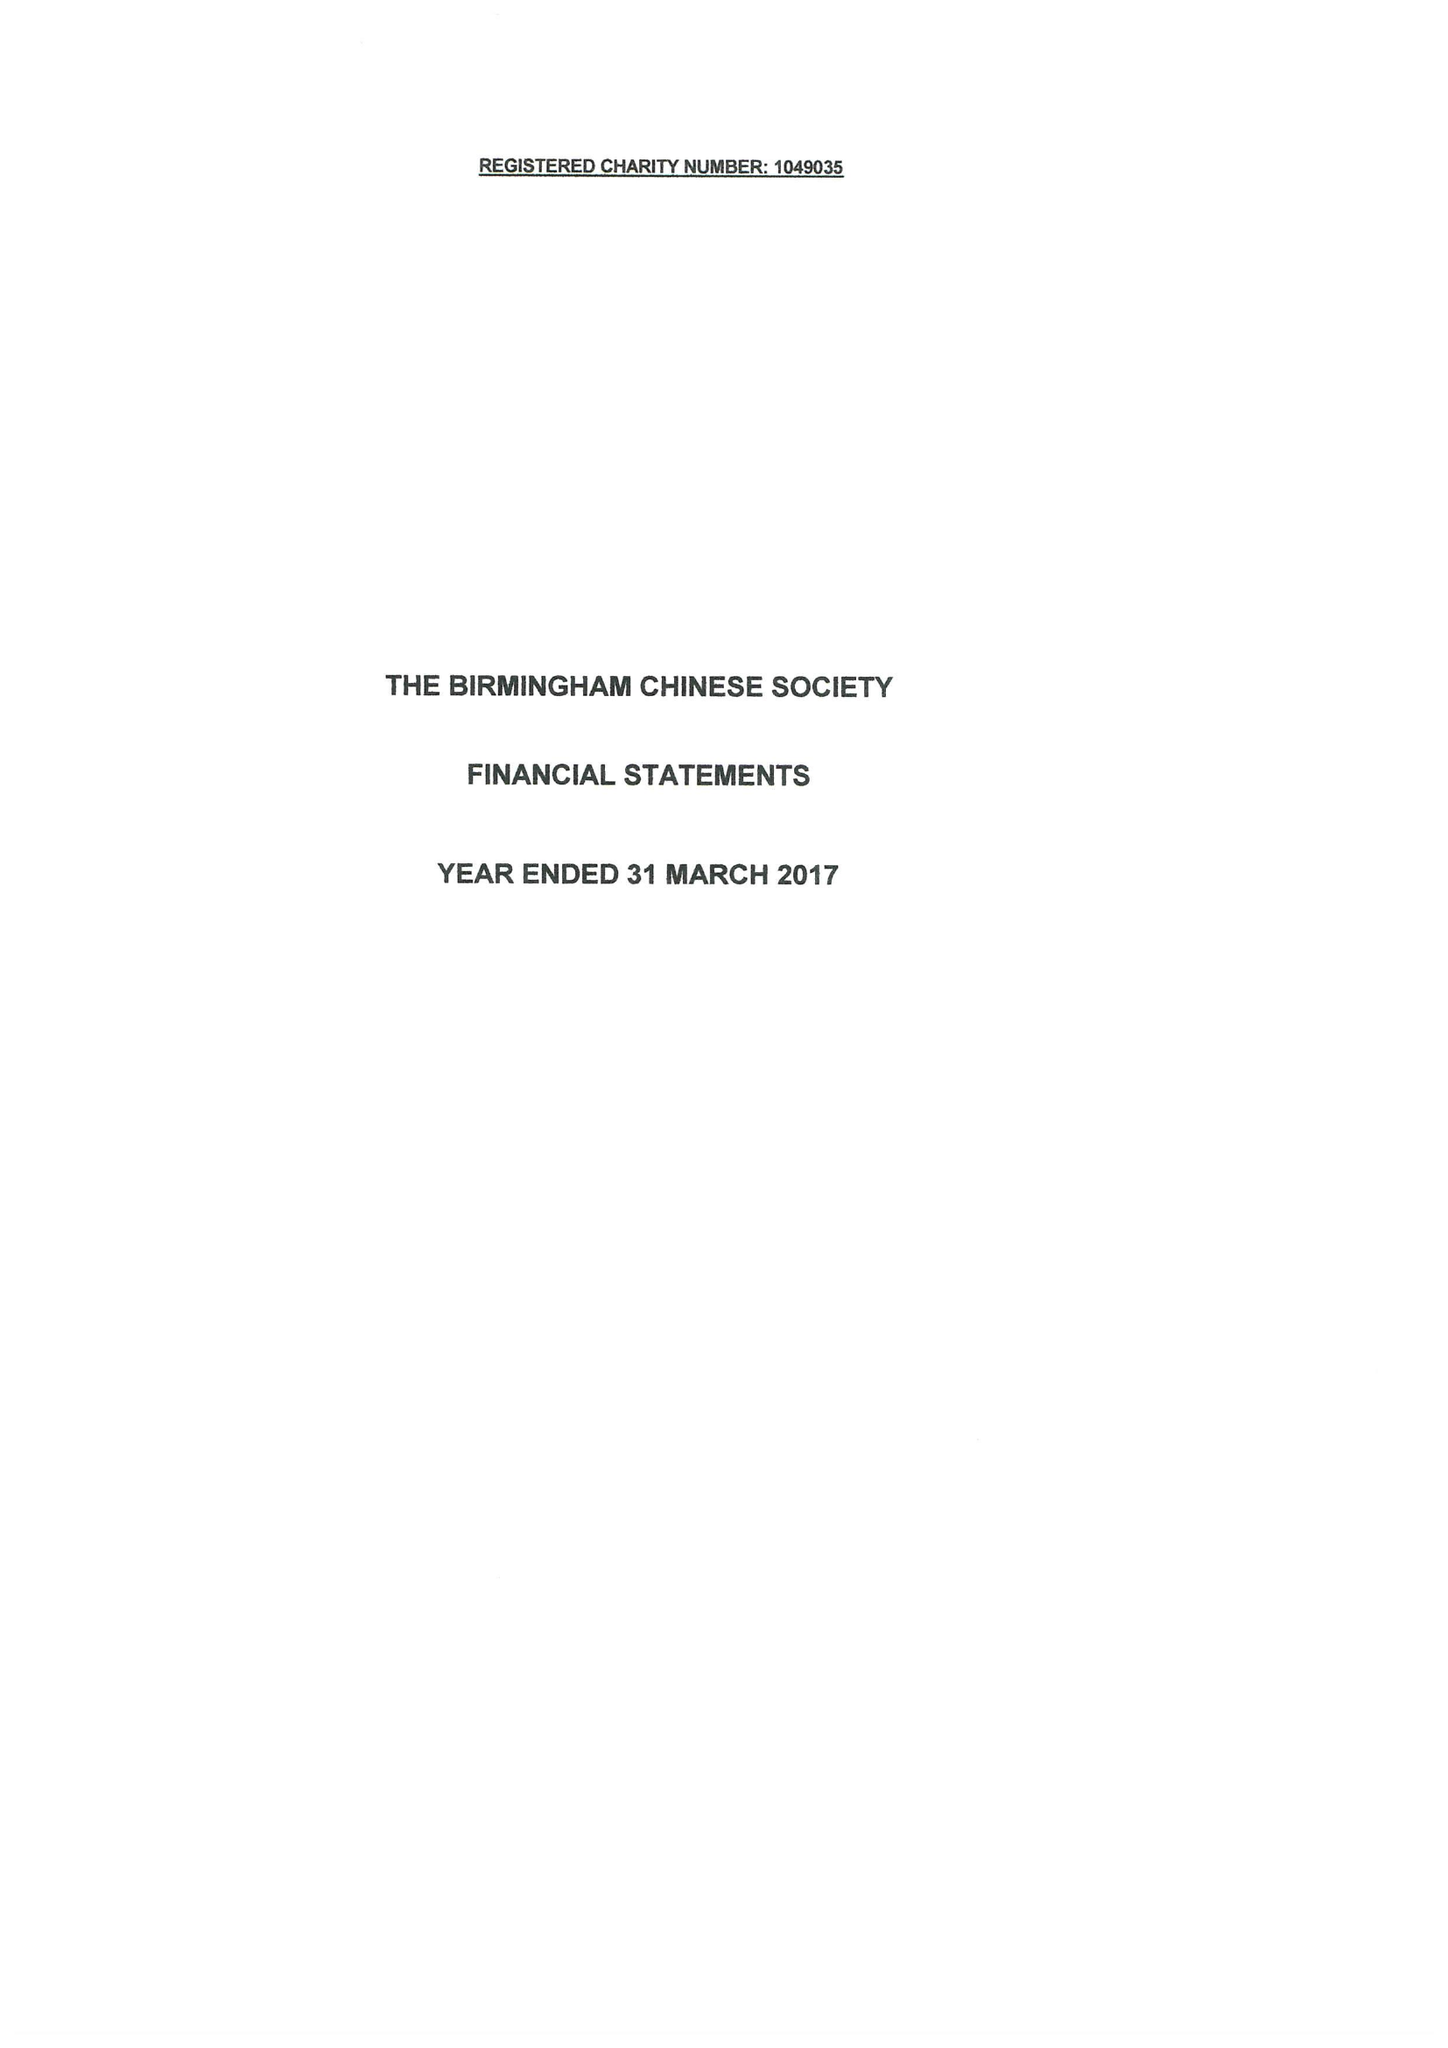What is the value for the address__postcode?
Answer the question using a single word or phrase. B9 4DY 